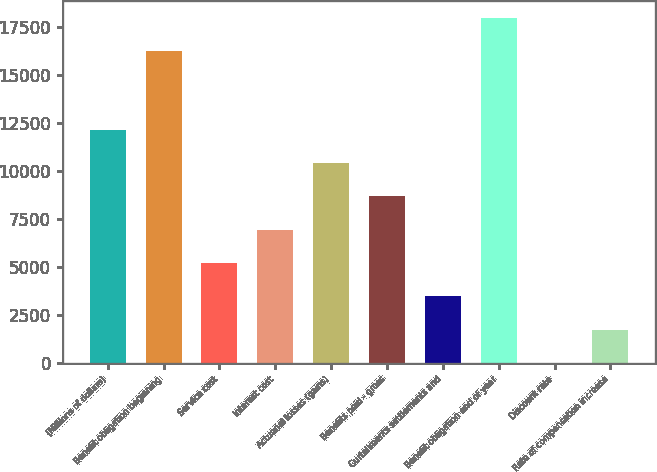Convert chart to OTSL. <chart><loc_0><loc_0><loc_500><loc_500><bar_chart><fcel>(Millions of dollars)<fcel>Benefit obligation beginning<fcel>Service cost<fcel>Interest cost<fcel>Actuarial losses (gains)<fcel>Benefits paid - gross<fcel>Curtailments settlements and<fcel>Benefit obligation end of year<fcel>Discount rate<fcel>Rate of compensation increase<nl><fcel>12129.2<fcel>16218<fcel>5200.25<fcel>6932.5<fcel>10397<fcel>8664.75<fcel>3468<fcel>17950.2<fcel>3.5<fcel>1735.75<nl></chart> 